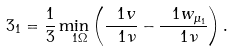<formula> <loc_0><loc_0><loc_500><loc_500>\ 3 _ { 1 } = \frac { 1 } { 3 } \min _ { \ 1 \Omega } \left ( \frac { \ 1 v } { \ 1 \nu } - \frac { \ 1 w _ { \mu _ { 1 } } } { \ 1 \nu } \right ) .</formula> 